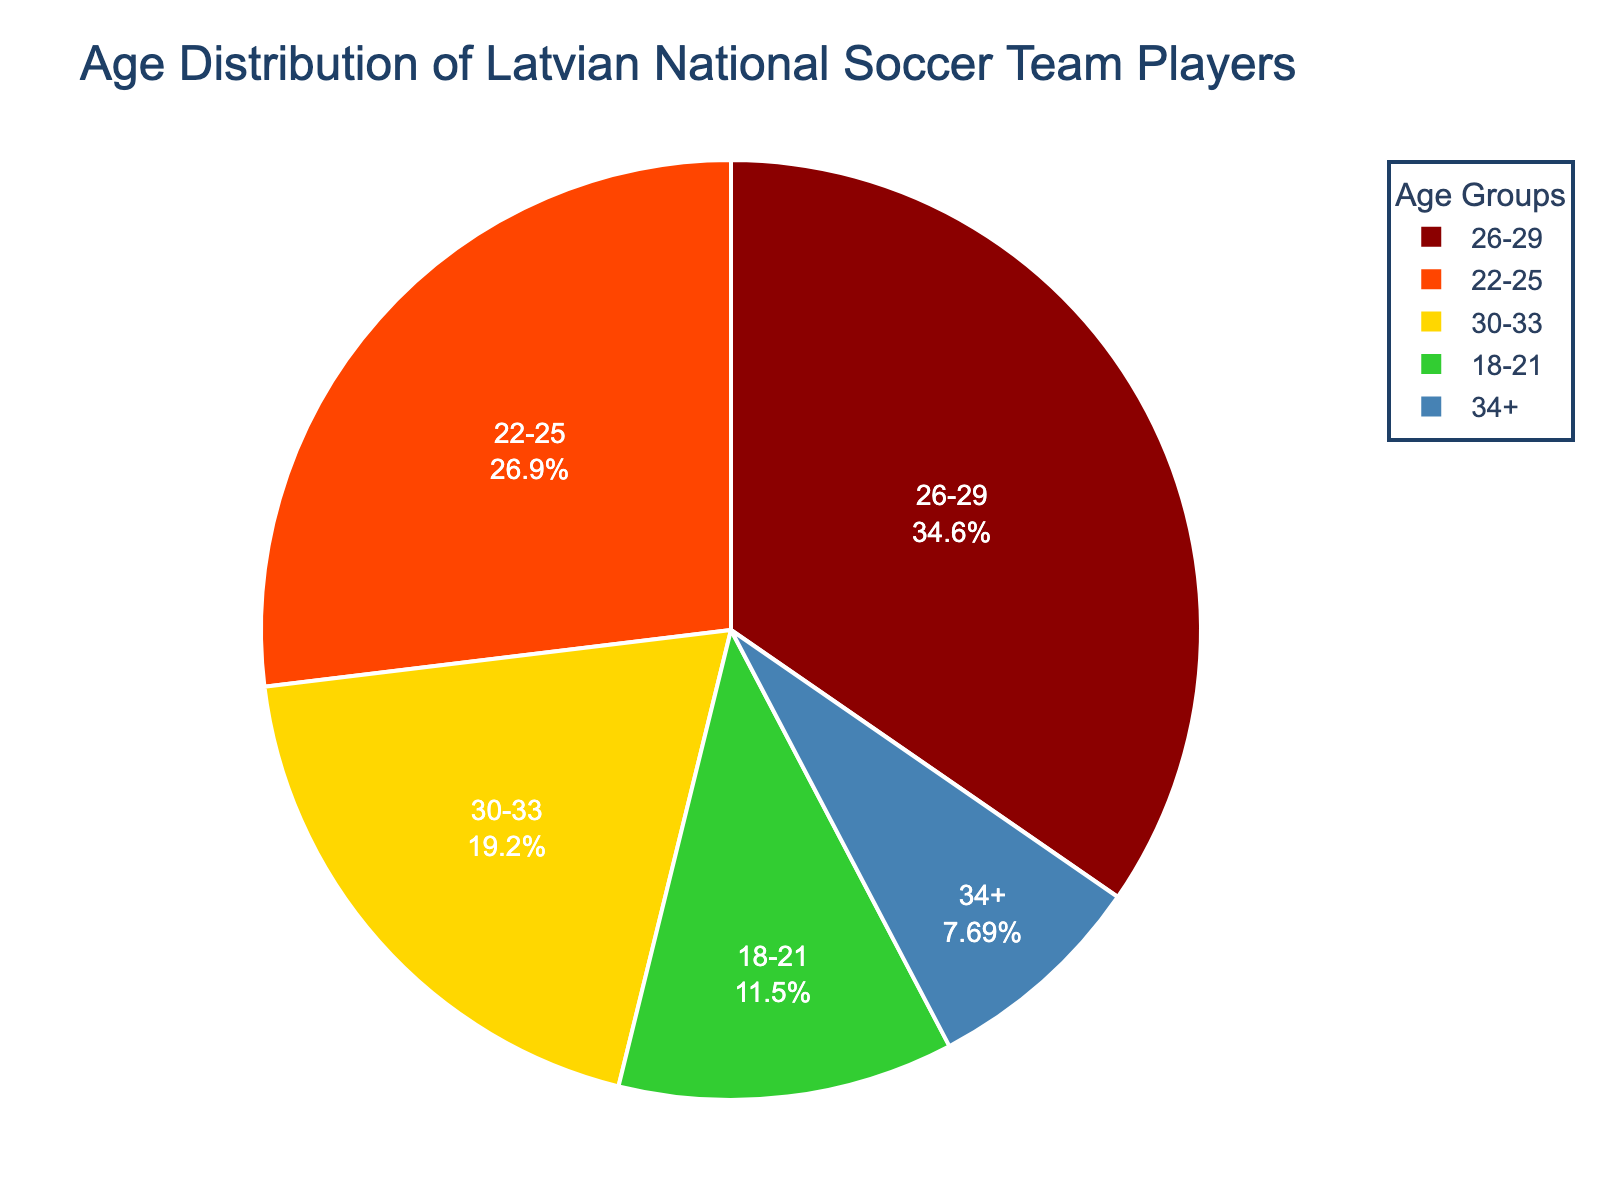What age group has the largest number of players? First, observe the segments of the pie chart and identify which segment is the largest in terms of size. The '26-29' age group has the largest segment.
Answer: 26-29 What percentage of players are in the '22-25' age group? Identify the '22-25' age group segment in the pie chart, and note the percentage label associated with this segment. It shows 28%.
Answer: 28% How many players are over 30 years old? Identify the '30-33' and '34+' segments in the pie chart and sum their numbers: 5 (for 30-33) + 2 (for 34+).
Answer: 7 Which age group has fewer players: '18-21' or '34+'? Compare the sizes of the '18-21' and '34+' segments in the pie chart by noting the count of players. '34+' has fewer players with 2 compared to 3 for '18-21'.
Answer: 34+ Is the number of players in the '26-29' age group greater than the combined number in the '18-21' and '34+' groups? Compare players in the '26-29' group (9 players) with the sum of players in '18-21' and '34+' groups (3 + 2 = 5). Since 9 is greater than 5, the answer is yes.
Answer: Yes How much larger is the '26-29' age group compared to the '30-33' age group? Subtract the number of players in the '30-33' age group (5) from the '26-29' age group (9). The difference is 9 - 5.
Answer: 4 What is the combined percentage of players aged '18-21' and '34+'? Add the percentages for the '18-21' (12%) and '34+' (8%) segments from the pie chart. The combined percentage is 12 + 8.
Answer: 20% Which age group is represented by the green color in the pie chart? Look at the pie chart and identify the green segment. The green color represents the '30-33' age group.
Answer: 30-33 What fraction of the team is between 22 and 29 years old? Sum up the number of players in '22-25' (7 players) and '26-29' (9 players) and divide by the total number of players (3 + 7 + 9 + 5 + 2 = 26). The fraction is (7 + 9) / 26.
Answer: 16/26 Which two age groups have the closest number of players? Compare the numbers of players for each age group. '22-25' (7 players) and '30-33' (5 players) have a difference of 2, which is the smallest difference among all pairs.
Answer: 22-25 and 30-33 